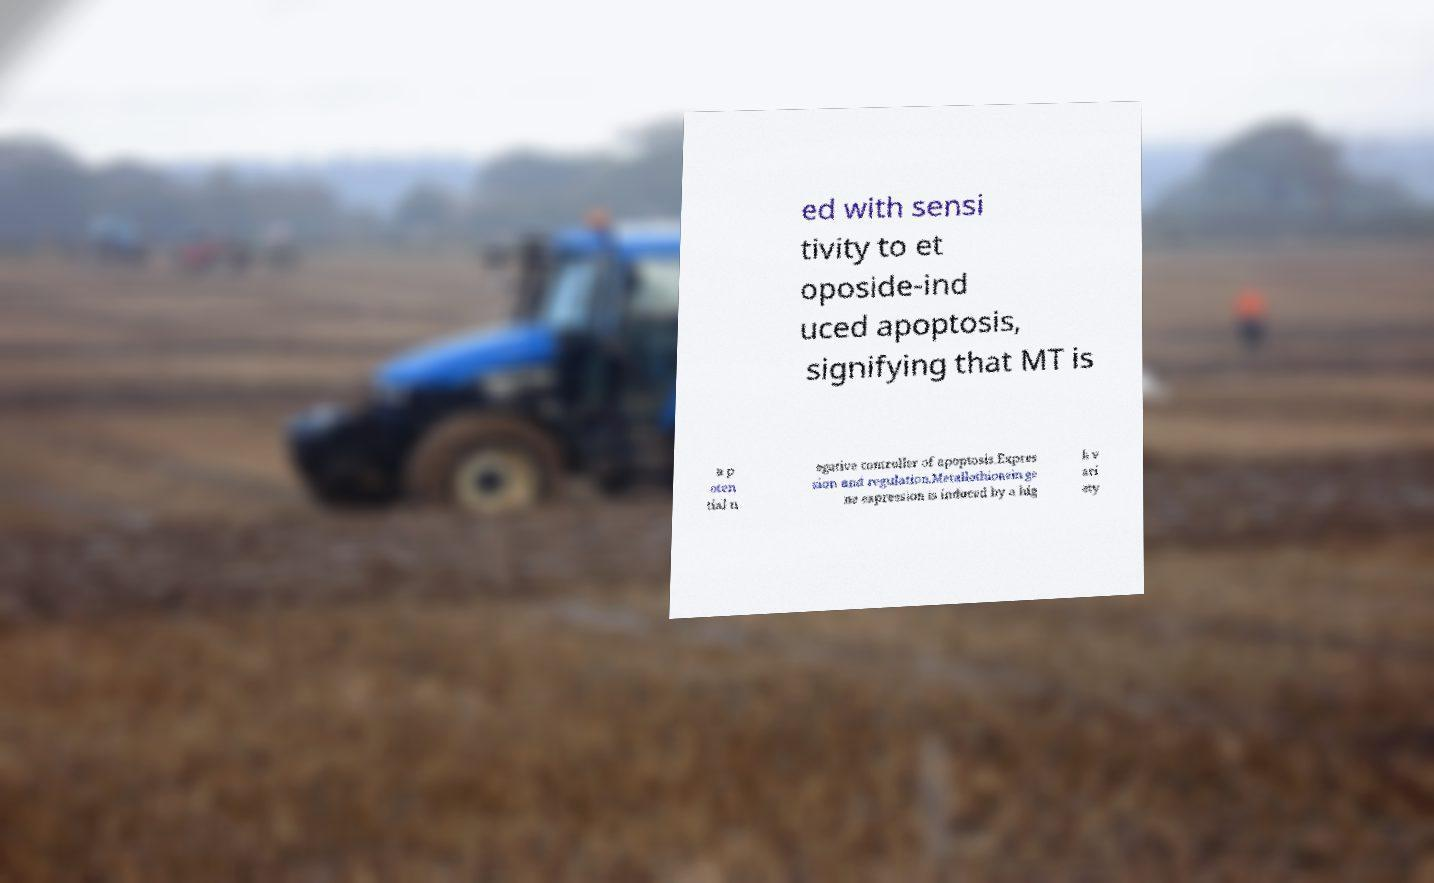Could you extract and type out the text from this image? ed with sensi tivity to et oposide-ind uced apoptosis, signifying that MT is a p oten tial n egative controller of apoptosis.Expres sion and regulation.Metallothionein ge ne expression is induced by a hig h v ari ety 